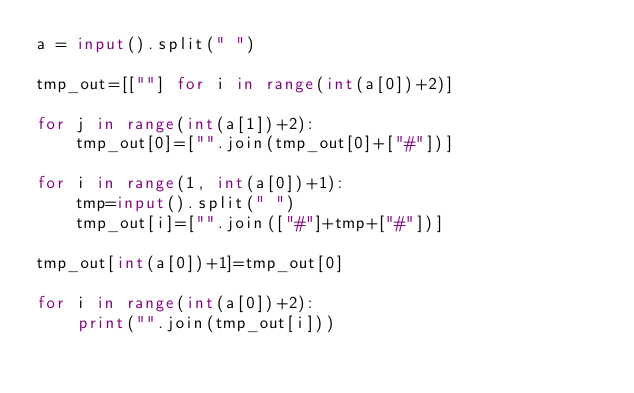Convert code to text. <code><loc_0><loc_0><loc_500><loc_500><_Python_>a = input().split(" ")

tmp_out=[[""] for i in range(int(a[0])+2)]

for j in range(int(a[1])+2):
    tmp_out[0]=["".join(tmp_out[0]+["#"])]

for i in range(1, int(a[0])+1):
    tmp=input().split(" ")
    tmp_out[i]=["".join(["#"]+tmp+["#"])]

tmp_out[int(a[0])+1]=tmp_out[0]

for i in range(int(a[0])+2):
    print("".join(tmp_out[i]))</code> 